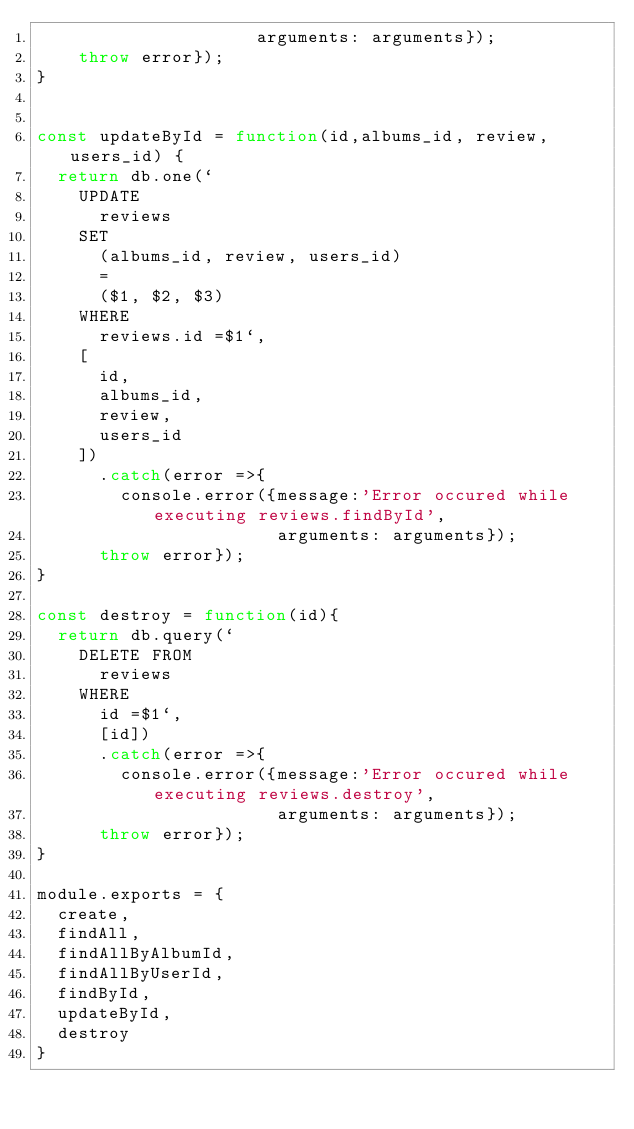<code> <loc_0><loc_0><loc_500><loc_500><_JavaScript_>                     arguments: arguments});
    throw error});
}


const updateById = function(id,albums_id, review, users_id) {
  return db.one(`
    UPDATE
      reviews
    SET
      (albums_id, review, users_id)
      =
      ($1, $2, $3)
    WHERE
      reviews.id =$1`,
    [
      id,
      albums_id,
      review,
      users_id
    ])
      .catch(error =>{
        console.error({message:'Error occured while executing reviews.findById',
                       arguments: arguments});
      throw error});
}

const destroy = function(id){
  return db.query(`
    DELETE FROM
      reviews
    WHERE
      id =$1`,
      [id])
      .catch(error =>{
        console.error({message:'Error occured while executing reviews.destroy',
                       arguments: arguments});
      throw error});
}

module.exports = {
  create,
  findAll,
  findAllByAlbumId,
  findAllByUserId,
  findById,
  updateById,
  destroy
}
</code> 